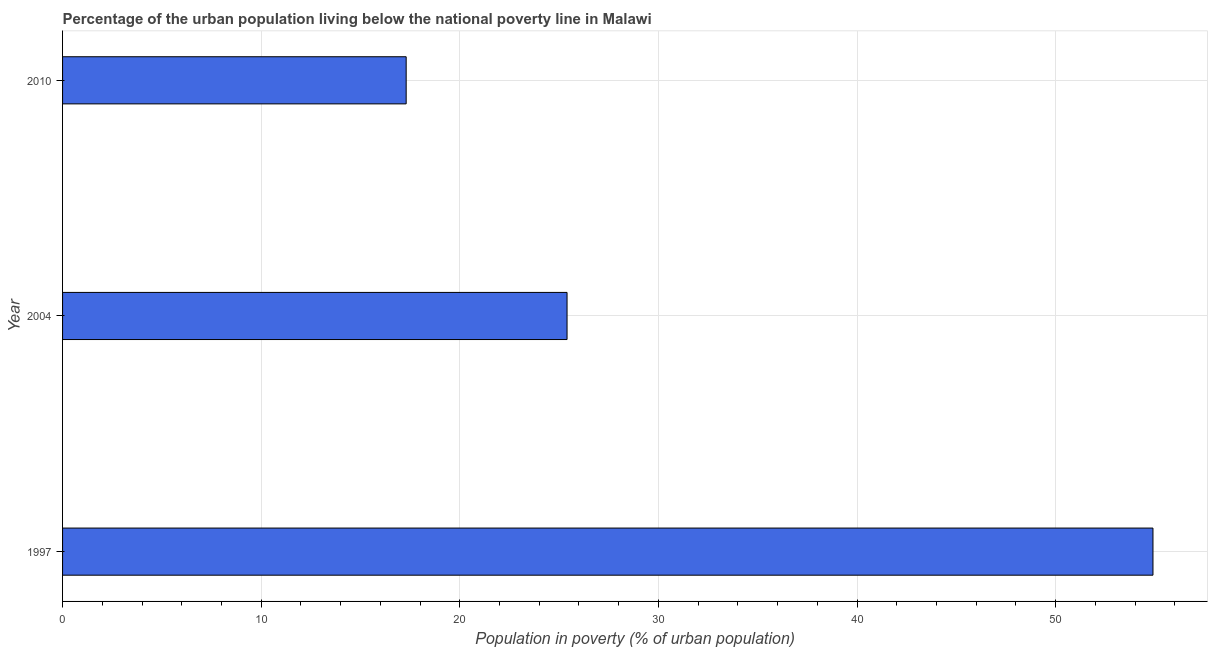What is the title of the graph?
Ensure brevity in your answer.  Percentage of the urban population living below the national poverty line in Malawi. What is the label or title of the X-axis?
Offer a very short reply. Population in poverty (% of urban population). What is the percentage of urban population living below poverty line in 2004?
Provide a short and direct response. 25.4. Across all years, what is the maximum percentage of urban population living below poverty line?
Keep it short and to the point. 54.9. Across all years, what is the minimum percentage of urban population living below poverty line?
Provide a short and direct response. 17.3. In which year was the percentage of urban population living below poverty line maximum?
Offer a very short reply. 1997. What is the sum of the percentage of urban population living below poverty line?
Keep it short and to the point. 97.6. What is the difference between the percentage of urban population living below poverty line in 1997 and 2004?
Keep it short and to the point. 29.5. What is the average percentage of urban population living below poverty line per year?
Give a very brief answer. 32.53. What is the median percentage of urban population living below poverty line?
Offer a very short reply. 25.4. What is the ratio of the percentage of urban population living below poverty line in 2004 to that in 2010?
Provide a succinct answer. 1.47. What is the difference between the highest and the second highest percentage of urban population living below poverty line?
Keep it short and to the point. 29.5. What is the difference between the highest and the lowest percentage of urban population living below poverty line?
Provide a succinct answer. 37.6. How many bars are there?
Your response must be concise. 3. Are the values on the major ticks of X-axis written in scientific E-notation?
Offer a terse response. No. What is the Population in poverty (% of urban population) in 1997?
Your answer should be very brief. 54.9. What is the Population in poverty (% of urban population) of 2004?
Offer a very short reply. 25.4. What is the difference between the Population in poverty (% of urban population) in 1997 and 2004?
Your answer should be very brief. 29.5. What is the difference between the Population in poverty (% of urban population) in 1997 and 2010?
Ensure brevity in your answer.  37.6. What is the ratio of the Population in poverty (% of urban population) in 1997 to that in 2004?
Offer a terse response. 2.16. What is the ratio of the Population in poverty (% of urban population) in 1997 to that in 2010?
Offer a very short reply. 3.17. What is the ratio of the Population in poverty (% of urban population) in 2004 to that in 2010?
Your response must be concise. 1.47. 